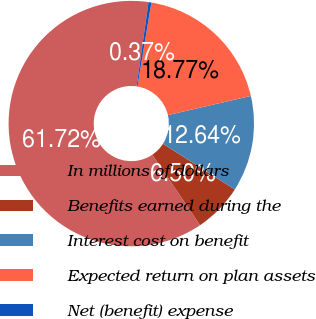<chart> <loc_0><loc_0><loc_500><loc_500><pie_chart><fcel>In millions of dollars<fcel>Benefits earned during the<fcel>Interest cost on benefit<fcel>Expected return on plan assets<fcel>Net (benefit) expense<nl><fcel>61.72%<fcel>6.5%<fcel>12.64%<fcel>18.77%<fcel>0.37%<nl></chart> 